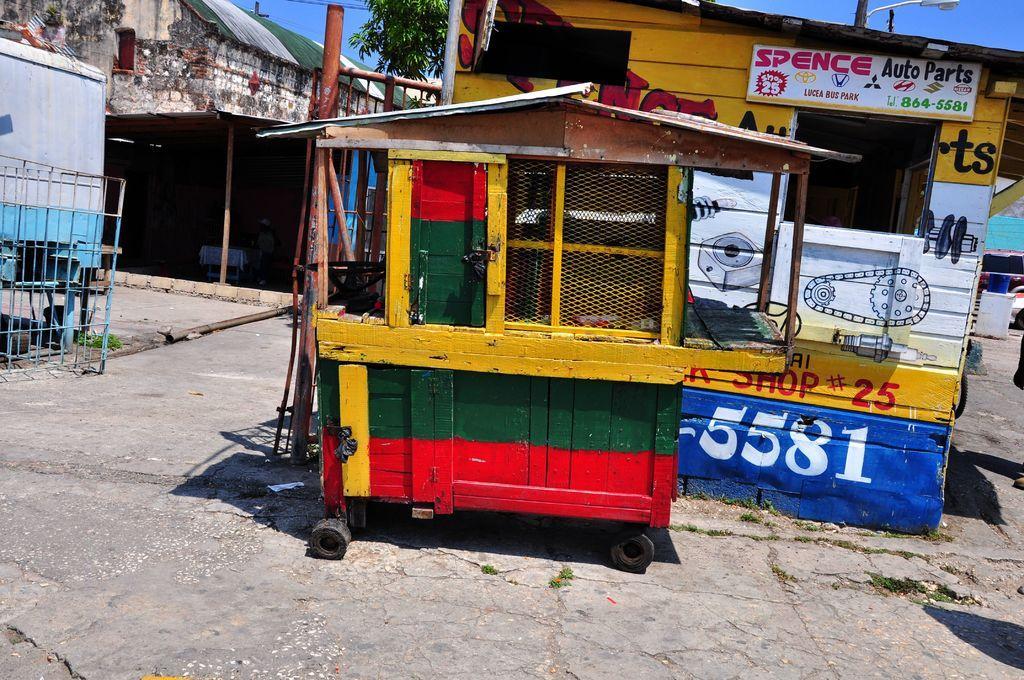Could you give a brief overview of what you see in this image? In front of the picture, we see a food truck cart in yellow, green and red color. Beside that, we see a pole. Behind that, we see a building in yellow, white and blue color. On top of the building, we see a board in white color with some text written on it. On the right side, we see a car and a white board. On the left side, we see the railing and a food truck cart in white and blue color. There are trees and a building in the background. At the top, we see the sky and at the bottom, we see the pavement. 